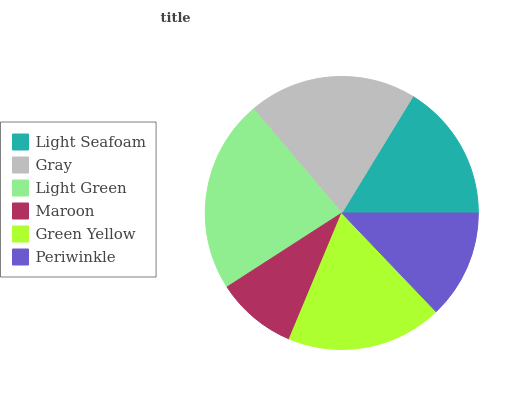Is Maroon the minimum?
Answer yes or no. Yes. Is Light Green the maximum?
Answer yes or no. Yes. Is Gray the minimum?
Answer yes or no. No. Is Gray the maximum?
Answer yes or no. No. Is Gray greater than Light Seafoam?
Answer yes or no. Yes. Is Light Seafoam less than Gray?
Answer yes or no. Yes. Is Light Seafoam greater than Gray?
Answer yes or no. No. Is Gray less than Light Seafoam?
Answer yes or no. No. Is Green Yellow the high median?
Answer yes or no. Yes. Is Light Seafoam the low median?
Answer yes or no. Yes. Is Light Green the high median?
Answer yes or no. No. Is Gray the low median?
Answer yes or no. No. 